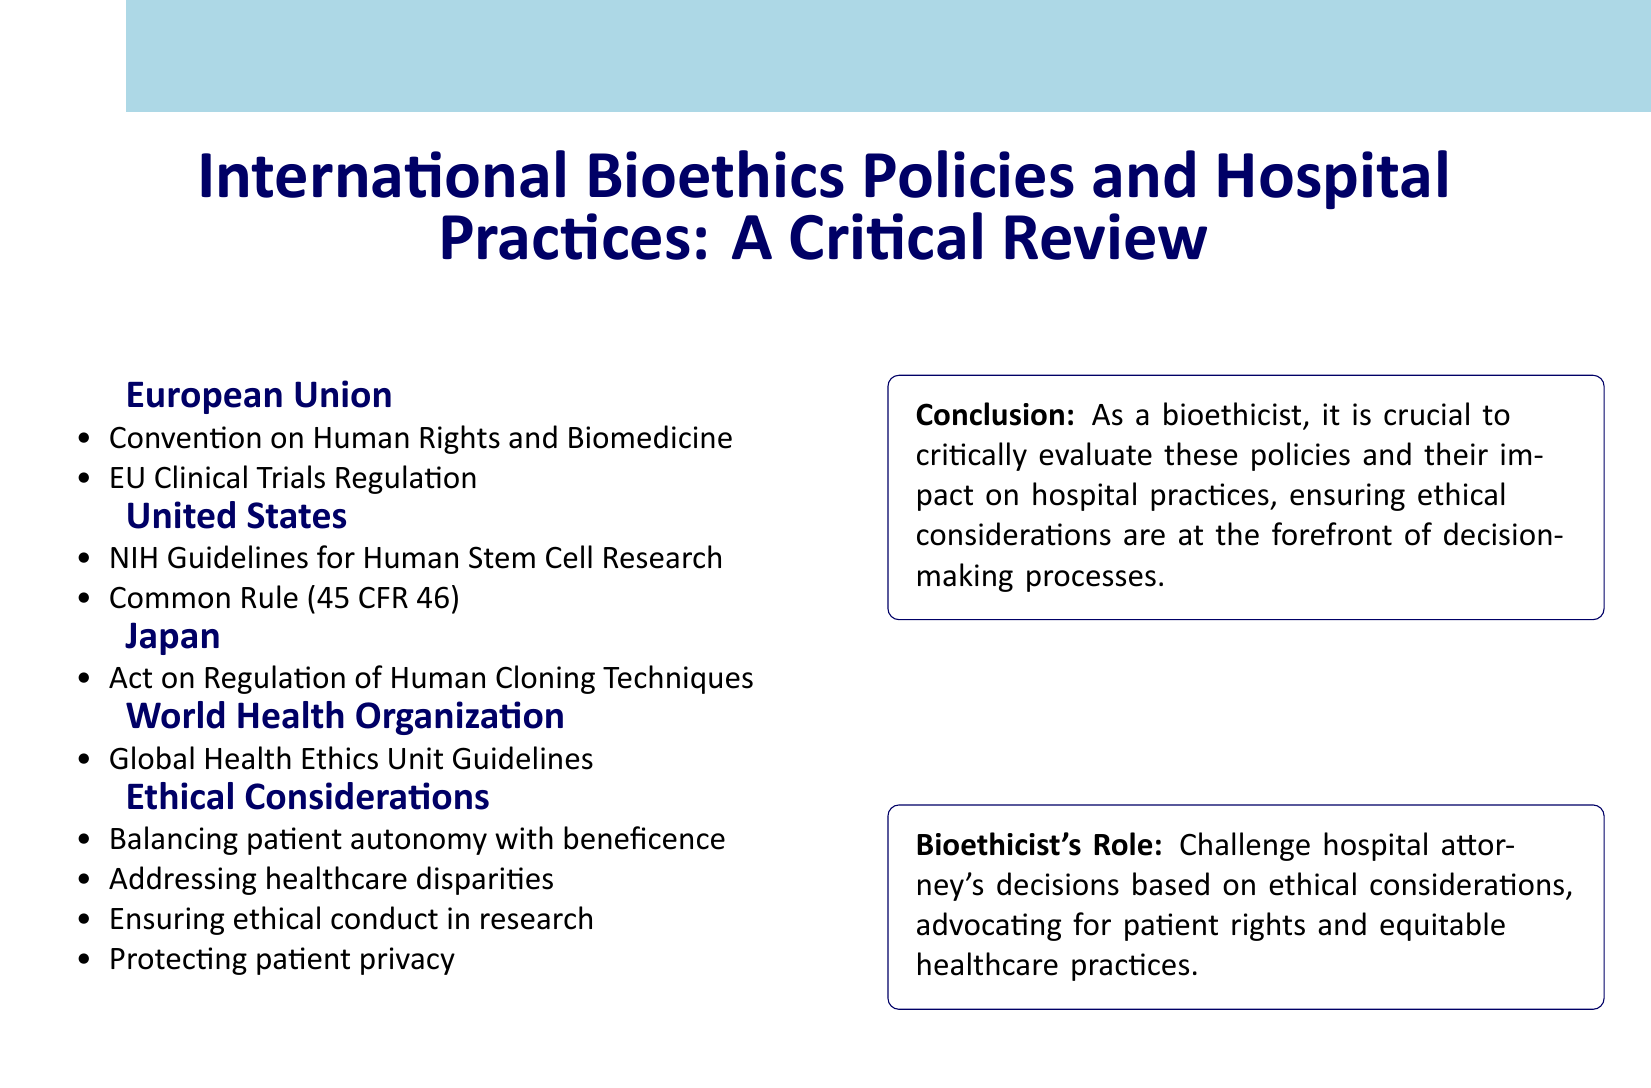What are two policies from the European Union? The document lists the "Convention on Human Rights and Biomedicine" and "EU Clinical Trials Regulation" as policies from the European Union.
Answer: Convention on Human Rights and Biomedicine, EU Clinical Trials Regulation What guidelines are provided by the World Health Organization? The document identifies "Global Health Ethics Unit Guidelines" as the guidelines provided by the World Health Organization.
Answer: Global Health Ethics Unit Guidelines What is the ethical consideration related to patient autonomy? The document states that it involves "balancing patient autonomy with beneficence."
Answer: balancing patient autonomy with beneficence How many countries' bioethics policies are reviewed in the document? The document reviews the bioethics policies from four regions: European Union, United States, Japan, and World Health Organization.
Answer: four What is the primary role of a bioethicist according to the document? The document mentions that a bioethicist's role is to "challenge hospital attorney's decisions based on ethical considerations."
Answer: challenge hospital attorney's decisions based on ethical considerations What does the document emphasize about healthcare? It emphasizes "addressing healthcare disparities" as a significant ethical consideration.
Answer: addressing healthcare disparities What type of document is this? The document is categorized as a "Critical Review" of international bioethics policies and hospital practices.
Answer: Critical Review What is one of the ethical considerations regarding research? The document states that ensuring "ethical conduct in research" is an important consideration.
Answer: ensuring ethical conduct in research 